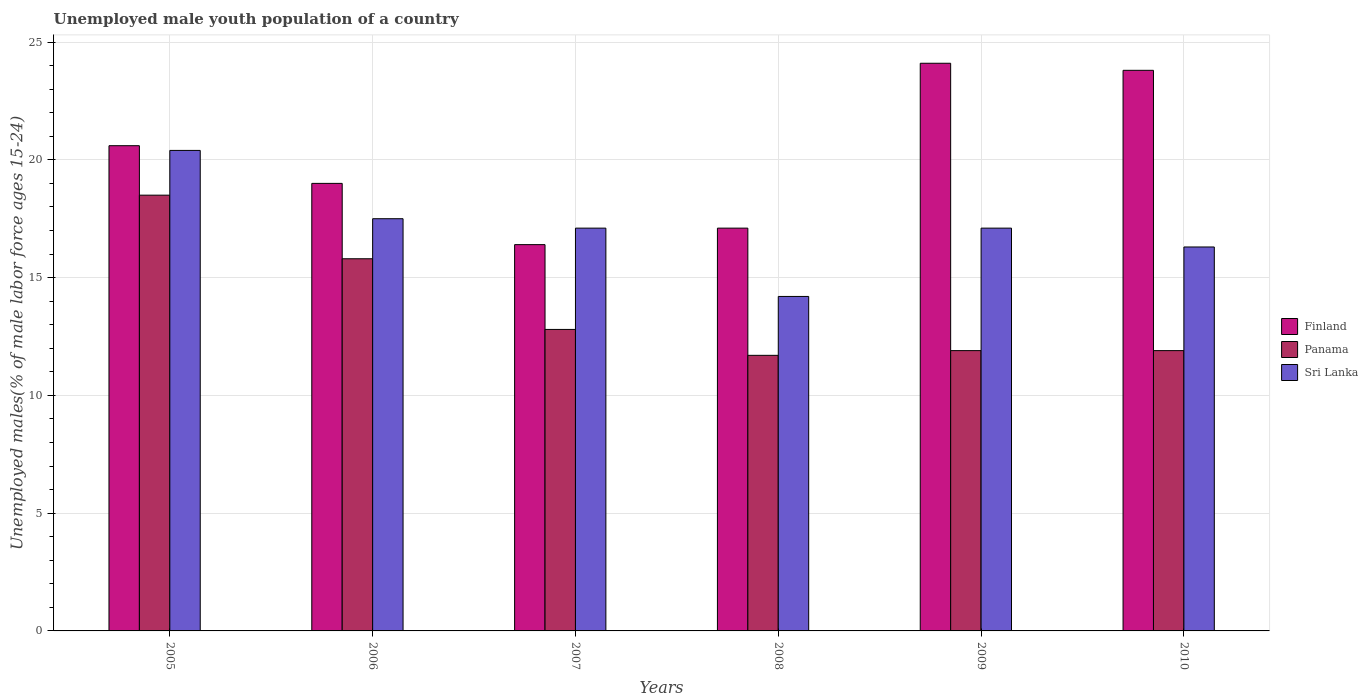How many different coloured bars are there?
Provide a succinct answer. 3. How many groups of bars are there?
Ensure brevity in your answer.  6. Are the number of bars per tick equal to the number of legend labels?
Make the answer very short. Yes. Are the number of bars on each tick of the X-axis equal?
Your response must be concise. Yes. What is the label of the 1st group of bars from the left?
Keep it short and to the point. 2005. In how many cases, is the number of bars for a given year not equal to the number of legend labels?
Keep it short and to the point. 0. What is the percentage of unemployed male youth population in Finland in 2006?
Ensure brevity in your answer.  19. Across all years, what is the minimum percentage of unemployed male youth population in Finland?
Make the answer very short. 16.4. In which year was the percentage of unemployed male youth population in Finland minimum?
Provide a succinct answer. 2007. What is the total percentage of unemployed male youth population in Finland in the graph?
Offer a terse response. 121. What is the difference between the percentage of unemployed male youth population in Sri Lanka in 2007 and that in 2008?
Ensure brevity in your answer.  2.9. What is the difference between the percentage of unemployed male youth population in Sri Lanka in 2005 and the percentage of unemployed male youth population in Finland in 2009?
Your response must be concise. -3.7. What is the average percentage of unemployed male youth population in Panama per year?
Your answer should be compact. 13.77. In the year 2009, what is the difference between the percentage of unemployed male youth population in Sri Lanka and percentage of unemployed male youth population in Panama?
Your answer should be very brief. 5.2. What is the ratio of the percentage of unemployed male youth population in Finland in 2008 to that in 2010?
Give a very brief answer. 0.72. Is the percentage of unemployed male youth population in Finland in 2009 less than that in 2010?
Your response must be concise. No. What is the difference between the highest and the second highest percentage of unemployed male youth population in Panama?
Make the answer very short. 2.7. What is the difference between the highest and the lowest percentage of unemployed male youth population in Panama?
Your answer should be compact. 6.8. Is the sum of the percentage of unemployed male youth population in Finland in 2006 and 2008 greater than the maximum percentage of unemployed male youth population in Sri Lanka across all years?
Give a very brief answer. Yes. Is it the case that in every year, the sum of the percentage of unemployed male youth population in Panama and percentage of unemployed male youth population in Sri Lanka is greater than the percentage of unemployed male youth population in Finland?
Your answer should be compact. Yes. Are all the bars in the graph horizontal?
Offer a very short reply. No. How many years are there in the graph?
Ensure brevity in your answer.  6. What is the difference between two consecutive major ticks on the Y-axis?
Your response must be concise. 5. Are the values on the major ticks of Y-axis written in scientific E-notation?
Your response must be concise. No. Does the graph contain grids?
Give a very brief answer. Yes. Where does the legend appear in the graph?
Your response must be concise. Center right. What is the title of the graph?
Your answer should be very brief. Unemployed male youth population of a country. What is the label or title of the X-axis?
Provide a succinct answer. Years. What is the label or title of the Y-axis?
Offer a very short reply. Unemployed males(% of male labor force ages 15-24). What is the Unemployed males(% of male labor force ages 15-24) in Finland in 2005?
Provide a short and direct response. 20.6. What is the Unemployed males(% of male labor force ages 15-24) of Panama in 2005?
Provide a succinct answer. 18.5. What is the Unemployed males(% of male labor force ages 15-24) of Sri Lanka in 2005?
Your answer should be very brief. 20.4. What is the Unemployed males(% of male labor force ages 15-24) of Finland in 2006?
Offer a terse response. 19. What is the Unemployed males(% of male labor force ages 15-24) of Panama in 2006?
Your response must be concise. 15.8. What is the Unemployed males(% of male labor force ages 15-24) of Finland in 2007?
Your response must be concise. 16.4. What is the Unemployed males(% of male labor force ages 15-24) of Panama in 2007?
Offer a terse response. 12.8. What is the Unemployed males(% of male labor force ages 15-24) in Sri Lanka in 2007?
Make the answer very short. 17.1. What is the Unemployed males(% of male labor force ages 15-24) of Finland in 2008?
Your answer should be compact. 17.1. What is the Unemployed males(% of male labor force ages 15-24) of Panama in 2008?
Provide a succinct answer. 11.7. What is the Unemployed males(% of male labor force ages 15-24) in Sri Lanka in 2008?
Provide a short and direct response. 14.2. What is the Unemployed males(% of male labor force ages 15-24) in Finland in 2009?
Offer a terse response. 24.1. What is the Unemployed males(% of male labor force ages 15-24) of Panama in 2009?
Your answer should be compact. 11.9. What is the Unemployed males(% of male labor force ages 15-24) of Sri Lanka in 2009?
Your answer should be very brief. 17.1. What is the Unemployed males(% of male labor force ages 15-24) in Finland in 2010?
Keep it short and to the point. 23.8. What is the Unemployed males(% of male labor force ages 15-24) in Panama in 2010?
Make the answer very short. 11.9. What is the Unemployed males(% of male labor force ages 15-24) of Sri Lanka in 2010?
Your answer should be very brief. 16.3. Across all years, what is the maximum Unemployed males(% of male labor force ages 15-24) in Finland?
Keep it short and to the point. 24.1. Across all years, what is the maximum Unemployed males(% of male labor force ages 15-24) of Panama?
Give a very brief answer. 18.5. Across all years, what is the maximum Unemployed males(% of male labor force ages 15-24) of Sri Lanka?
Give a very brief answer. 20.4. Across all years, what is the minimum Unemployed males(% of male labor force ages 15-24) of Finland?
Keep it short and to the point. 16.4. Across all years, what is the minimum Unemployed males(% of male labor force ages 15-24) in Panama?
Give a very brief answer. 11.7. Across all years, what is the minimum Unemployed males(% of male labor force ages 15-24) in Sri Lanka?
Keep it short and to the point. 14.2. What is the total Unemployed males(% of male labor force ages 15-24) in Finland in the graph?
Your answer should be compact. 121. What is the total Unemployed males(% of male labor force ages 15-24) in Panama in the graph?
Ensure brevity in your answer.  82.6. What is the total Unemployed males(% of male labor force ages 15-24) in Sri Lanka in the graph?
Your answer should be very brief. 102.6. What is the difference between the Unemployed males(% of male labor force ages 15-24) of Panama in 2005 and that in 2006?
Offer a very short reply. 2.7. What is the difference between the Unemployed males(% of male labor force ages 15-24) of Panama in 2005 and that in 2007?
Give a very brief answer. 5.7. What is the difference between the Unemployed males(% of male labor force ages 15-24) of Finland in 2005 and that in 2008?
Your answer should be compact. 3.5. What is the difference between the Unemployed males(% of male labor force ages 15-24) of Sri Lanka in 2005 and that in 2008?
Keep it short and to the point. 6.2. What is the difference between the Unemployed males(% of male labor force ages 15-24) in Sri Lanka in 2005 and that in 2010?
Offer a terse response. 4.1. What is the difference between the Unemployed males(% of male labor force ages 15-24) in Sri Lanka in 2006 and that in 2007?
Offer a very short reply. 0.4. What is the difference between the Unemployed males(% of male labor force ages 15-24) of Sri Lanka in 2006 and that in 2008?
Offer a terse response. 3.3. What is the difference between the Unemployed males(% of male labor force ages 15-24) in Finland in 2006 and that in 2009?
Offer a very short reply. -5.1. What is the difference between the Unemployed males(% of male labor force ages 15-24) in Panama in 2006 and that in 2010?
Provide a short and direct response. 3.9. What is the difference between the Unemployed males(% of male labor force ages 15-24) of Sri Lanka in 2006 and that in 2010?
Your answer should be compact. 1.2. What is the difference between the Unemployed males(% of male labor force ages 15-24) of Panama in 2007 and that in 2008?
Your answer should be very brief. 1.1. What is the difference between the Unemployed males(% of male labor force ages 15-24) in Sri Lanka in 2007 and that in 2008?
Your answer should be very brief. 2.9. What is the difference between the Unemployed males(% of male labor force ages 15-24) in Sri Lanka in 2007 and that in 2009?
Make the answer very short. 0. What is the difference between the Unemployed males(% of male labor force ages 15-24) of Finland in 2007 and that in 2010?
Provide a short and direct response. -7.4. What is the difference between the Unemployed males(% of male labor force ages 15-24) in Panama in 2008 and that in 2009?
Keep it short and to the point. -0.2. What is the difference between the Unemployed males(% of male labor force ages 15-24) of Panama in 2008 and that in 2010?
Your answer should be very brief. -0.2. What is the difference between the Unemployed males(% of male labor force ages 15-24) in Sri Lanka in 2008 and that in 2010?
Offer a terse response. -2.1. What is the difference between the Unemployed males(% of male labor force ages 15-24) of Finland in 2009 and that in 2010?
Keep it short and to the point. 0.3. What is the difference between the Unemployed males(% of male labor force ages 15-24) of Sri Lanka in 2009 and that in 2010?
Make the answer very short. 0.8. What is the difference between the Unemployed males(% of male labor force ages 15-24) in Finland in 2005 and the Unemployed males(% of male labor force ages 15-24) in Panama in 2006?
Provide a short and direct response. 4.8. What is the difference between the Unemployed males(% of male labor force ages 15-24) of Finland in 2005 and the Unemployed males(% of male labor force ages 15-24) of Sri Lanka in 2007?
Ensure brevity in your answer.  3.5. What is the difference between the Unemployed males(% of male labor force ages 15-24) in Panama in 2005 and the Unemployed males(% of male labor force ages 15-24) in Sri Lanka in 2007?
Your answer should be very brief. 1.4. What is the difference between the Unemployed males(% of male labor force ages 15-24) of Finland in 2005 and the Unemployed males(% of male labor force ages 15-24) of Panama in 2008?
Your response must be concise. 8.9. What is the difference between the Unemployed males(% of male labor force ages 15-24) of Finland in 2005 and the Unemployed males(% of male labor force ages 15-24) of Sri Lanka in 2008?
Provide a succinct answer. 6.4. What is the difference between the Unemployed males(% of male labor force ages 15-24) of Panama in 2005 and the Unemployed males(% of male labor force ages 15-24) of Sri Lanka in 2008?
Ensure brevity in your answer.  4.3. What is the difference between the Unemployed males(% of male labor force ages 15-24) in Finland in 2005 and the Unemployed males(% of male labor force ages 15-24) in Sri Lanka in 2009?
Offer a terse response. 3.5. What is the difference between the Unemployed males(% of male labor force ages 15-24) of Panama in 2005 and the Unemployed males(% of male labor force ages 15-24) of Sri Lanka in 2009?
Provide a short and direct response. 1.4. What is the difference between the Unemployed males(% of male labor force ages 15-24) of Finland in 2005 and the Unemployed males(% of male labor force ages 15-24) of Panama in 2010?
Offer a terse response. 8.7. What is the difference between the Unemployed males(% of male labor force ages 15-24) in Panama in 2006 and the Unemployed males(% of male labor force ages 15-24) in Sri Lanka in 2007?
Offer a terse response. -1.3. What is the difference between the Unemployed males(% of male labor force ages 15-24) of Finland in 2006 and the Unemployed males(% of male labor force ages 15-24) of Panama in 2008?
Your response must be concise. 7.3. What is the difference between the Unemployed males(% of male labor force ages 15-24) of Panama in 2006 and the Unemployed males(% of male labor force ages 15-24) of Sri Lanka in 2008?
Offer a very short reply. 1.6. What is the difference between the Unemployed males(% of male labor force ages 15-24) in Finland in 2006 and the Unemployed males(% of male labor force ages 15-24) in Panama in 2010?
Your response must be concise. 7.1. What is the difference between the Unemployed males(% of male labor force ages 15-24) in Finland in 2006 and the Unemployed males(% of male labor force ages 15-24) in Sri Lanka in 2010?
Offer a terse response. 2.7. What is the difference between the Unemployed males(% of male labor force ages 15-24) in Panama in 2006 and the Unemployed males(% of male labor force ages 15-24) in Sri Lanka in 2010?
Offer a terse response. -0.5. What is the difference between the Unemployed males(% of male labor force ages 15-24) in Panama in 2007 and the Unemployed males(% of male labor force ages 15-24) in Sri Lanka in 2008?
Your answer should be very brief. -1.4. What is the difference between the Unemployed males(% of male labor force ages 15-24) of Finland in 2007 and the Unemployed males(% of male labor force ages 15-24) of Panama in 2009?
Your answer should be very brief. 4.5. What is the difference between the Unemployed males(% of male labor force ages 15-24) in Finland in 2007 and the Unemployed males(% of male labor force ages 15-24) in Sri Lanka in 2009?
Provide a succinct answer. -0.7. What is the difference between the Unemployed males(% of male labor force ages 15-24) in Panama in 2007 and the Unemployed males(% of male labor force ages 15-24) in Sri Lanka in 2009?
Your response must be concise. -4.3. What is the difference between the Unemployed males(% of male labor force ages 15-24) in Finland in 2007 and the Unemployed males(% of male labor force ages 15-24) in Sri Lanka in 2010?
Offer a very short reply. 0.1. What is the difference between the Unemployed males(% of male labor force ages 15-24) of Finland in 2008 and the Unemployed males(% of male labor force ages 15-24) of Panama in 2009?
Give a very brief answer. 5.2. What is the difference between the Unemployed males(% of male labor force ages 15-24) of Finland in 2008 and the Unemployed males(% of male labor force ages 15-24) of Sri Lanka in 2009?
Keep it short and to the point. 0. What is the difference between the Unemployed males(% of male labor force ages 15-24) in Panama in 2008 and the Unemployed males(% of male labor force ages 15-24) in Sri Lanka in 2009?
Offer a terse response. -5.4. What is the difference between the Unemployed males(% of male labor force ages 15-24) of Finland in 2008 and the Unemployed males(% of male labor force ages 15-24) of Panama in 2010?
Your answer should be very brief. 5.2. What is the difference between the Unemployed males(% of male labor force ages 15-24) of Finland in 2008 and the Unemployed males(% of male labor force ages 15-24) of Sri Lanka in 2010?
Your response must be concise. 0.8. What is the difference between the Unemployed males(% of male labor force ages 15-24) in Panama in 2008 and the Unemployed males(% of male labor force ages 15-24) in Sri Lanka in 2010?
Make the answer very short. -4.6. What is the difference between the Unemployed males(% of male labor force ages 15-24) of Finland in 2009 and the Unemployed males(% of male labor force ages 15-24) of Sri Lanka in 2010?
Provide a short and direct response. 7.8. What is the average Unemployed males(% of male labor force ages 15-24) in Finland per year?
Your response must be concise. 20.17. What is the average Unemployed males(% of male labor force ages 15-24) in Panama per year?
Offer a very short reply. 13.77. What is the average Unemployed males(% of male labor force ages 15-24) of Sri Lanka per year?
Provide a succinct answer. 17.1. In the year 2005, what is the difference between the Unemployed males(% of male labor force ages 15-24) of Finland and Unemployed males(% of male labor force ages 15-24) of Sri Lanka?
Provide a succinct answer. 0.2. In the year 2006, what is the difference between the Unemployed males(% of male labor force ages 15-24) in Panama and Unemployed males(% of male labor force ages 15-24) in Sri Lanka?
Your response must be concise. -1.7. In the year 2007, what is the difference between the Unemployed males(% of male labor force ages 15-24) in Finland and Unemployed males(% of male labor force ages 15-24) in Sri Lanka?
Your answer should be very brief. -0.7. In the year 2008, what is the difference between the Unemployed males(% of male labor force ages 15-24) of Finland and Unemployed males(% of male labor force ages 15-24) of Panama?
Your answer should be very brief. 5.4. In the year 2008, what is the difference between the Unemployed males(% of male labor force ages 15-24) of Finland and Unemployed males(% of male labor force ages 15-24) of Sri Lanka?
Offer a very short reply. 2.9. In the year 2008, what is the difference between the Unemployed males(% of male labor force ages 15-24) of Panama and Unemployed males(% of male labor force ages 15-24) of Sri Lanka?
Give a very brief answer. -2.5. In the year 2009, what is the difference between the Unemployed males(% of male labor force ages 15-24) in Finland and Unemployed males(% of male labor force ages 15-24) in Sri Lanka?
Make the answer very short. 7. In the year 2009, what is the difference between the Unemployed males(% of male labor force ages 15-24) of Panama and Unemployed males(% of male labor force ages 15-24) of Sri Lanka?
Your response must be concise. -5.2. In the year 2010, what is the difference between the Unemployed males(% of male labor force ages 15-24) in Finland and Unemployed males(% of male labor force ages 15-24) in Panama?
Your answer should be very brief. 11.9. In the year 2010, what is the difference between the Unemployed males(% of male labor force ages 15-24) of Finland and Unemployed males(% of male labor force ages 15-24) of Sri Lanka?
Your answer should be very brief. 7.5. What is the ratio of the Unemployed males(% of male labor force ages 15-24) in Finland in 2005 to that in 2006?
Keep it short and to the point. 1.08. What is the ratio of the Unemployed males(% of male labor force ages 15-24) in Panama in 2005 to that in 2006?
Offer a very short reply. 1.17. What is the ratio of the Unemployed males(% of male labor force ages 15-24) of Sri Lanka in 2005 to that in 2006?
Give a very brief answer. 1.17. What is the ratio of the Unemployed males(% of male labor force ages 15-24) of Finland in 2005 to that in 2007?
Your answer should be compact. 1.26. What is the ratio of the Unemployed males(% of male labor force ages 15-24) in Panama in 2005 to that in 2007?
Keep it short and to the point. 1.45. What is the ratio of the Unemployed males(% of male labor force ages 15-24) of Sri Lanka in 2005 to that in 2007?
Provide a short and direct response. 1.19. What is the ratio of the Unemployed males(% of male labor force ages 15-24) of Finland in 2005 to that in 2008?
Provide a short and direct response. 1.2. What is the ratio of the Unemployed males(% of male labor force ages 15-24) in Panama in 2005 to that in 2008?
Your answer should be compact. 1.58. What is the ratio of the Unemployed males(% of male labor force ages 15-24) of Sri Lanka in 2005 to that in 2008?
Your response must be concise. 1.44. What is the ratio of the Unemployed males(% of male labor force ages 15-24) in Finland in 2005 to that in 2009?
Keep it short and to the point. 0.85. What is the ratio of the Unemployed males(% of male labor force ages 15-24) of Panama in 2005 to that in 2009?
Offer a terse response. 1.55. What is the ratio of the Unemployed males(% of male labor force ages 15-24) of Sri Lanka in 2005 to that in 2009?
Your response must be concise. 1.19. What is the ratio of the Unemployed males(% of male labor force ages 15-24) in Finland in 2005 to that in 2010?
Your answer should be compact. 0.87. What is the ratio of the Unemployed males(% of male labor force ages 15-24) in Panama in 2005 to that in 2010?
Ensure brevity in your answer.  1.55. What is the ratio of the Unemployed males(% of male labor force ages 15-24) of Sri Lanka in 2005 to that in 2010?
Give a very brief answer. 1.25. What is the ratio of the Unemployed males(% of male labor force ages 15-24) in Finland in 2006 to that in 2007?
Offer a very short reply. 1.16. What is the ratio of the Unemployed males(% of male labor force ages 15-24) in Panama in 2006 to that in 2007?
Your answer should be very brief. 1.23. What is the ratio of the Unemployed males(% of male labor force ages 15-24) in Sri Lanka in 2006 to that in 2007?
Ensure brevity in your answer.  1.02. What is the ratio of the Unemployed males(% of male labor force ages 15-24) in Finland in 2006 to that in 2008?
Offer a very short reply. 1.11. What is the ratio of the Unemployed males(% of male labor force ages 15-24) of Panama in 2006 to that in 2008?
Your answer should be very brief. 1.35. What is the ratio of the Unemployed males(% of male labor force ages 15-24) in Sri Lanka in 2006 to that in 2008?
Make the answer very short. 1.23. What is the ratio of the Unemployed males(% of male labor force ages 15-24) in Finland in 2006 to that in 2009?
Provide a short and direct response. 0.79. What is the ratio of the Unemployed males(% of male labor force ages 15-24) of Panama in 2006 to that in 2009?
Give a very brief answer. 1.33. What is the ratio of the Unemployed males(% of male labor force ages 15-24) in Sri Lanka in 2006 to that in 2009?
Give a very brief answer. 1.02. What is the ratio of the Unemployed males(% of male labor force ages 15-24) of Finland in 2006 to that in 2010?
Your response must be concise. 0.8. What is the ratio of the Unemployed males(% of male labor force ages 15-24) in Panama in 2006 to that in 2010?
Provide a succinct answer. 1.33. What is the ratio of the Unemployed males(% of male labor force ages 15-24) of Sri Lanka in 2006 to that in 2010?
Your response must be concise. 1.07. What is the ratio of the Unemployed males(% of male labor force ages 15-24) of Finland in 2007 to that in 2008?
Ensure brevity in your answer.  0.96. What is the ratio of the Unemployed males(% of male labor force ages 15-24) in Panama in 2007 to that in 2008?
Your response must be concise. 1.09. What is the ratio of the Unemployed males(% of male labor force ages 15-24) in Sri Lanka in 2007 to that in 2008?
Provide a short and direct response. 1.2. What is the ratio of the Unemployed males(% of male labor force ages 15-24) in Finland in 2007 to that in 2009?
Give a very brief answer. 0.68. What is the ratio of the Unemployed males(% of male labor force ages 15-24) of Panama in 2007 to that in 2009?
Your response must be concise. 1.08. What is the ratio of the Unemployed males(% of male labor force ages 15-24) in Sri Lanka in 2007 to that in 2009?
Your response must be concise. 1. What is the ratio of the Unemployed males(% of male labor force ages 15-24) in Finland in 2007 to that in 2010?
Offer a terse response. 0.69. What is the ratio of the Unemployed males(% of male labor force ages 15-24) of Panama in 2007 to that in 2010?
Provide a short and direct response. 1.08. What is the ratio of the Unemployed males(% of male labor force ages 15-24) of Sri Lanka in 2007 to that in 2010?
Offer a terse response. 1.05. What is the ratio of the Unemployed males(% of male labor force ages 15-24) of Finland in 2008 to that in 2009?
Ensure brevity in your answer.  0.71. What is the ratio of the Unemployed males(% of male labor force ages 15-24) in Panama in 2008 to that in 2009?
Ensure brevity in your answer.  0.98. What is the ratio of the Unemployed males(% of male labor force ages 15-24) of Sri Lanka in 2008 to that in 2009?
Provide a succinct answer. 0.83. What is the ratio of the Unemployed males(% of male labor force ages 15-24) of Finland in 2008 to that in 2010?
Offer a very short reply. 0.72. What is the ratio of the Unemployed males(% of male labor force ages 15-24) in Panama in 2008 to that in 2010?
Your answer should be compact. 0.98. What is the ratio of the Unemployed males(% of male labor force ages 15-24) in Sri Lanka in 2008 to that in 2010?
Offer a terse response. 0.87. What is the ratio of the Unemployed males(% of male labor force ages 15-24) of Finland in 2009 to that in 2010?
Offer a terse response. 1.01. What is the ratio of the Unemployed males(% of male labor force ages 15-24) of Sri Lanka in 2009 to that in 2010?
Make the answer very short. 1.05. What is the difference between the highest and the second highest Unemployed males(% of male labor force ages 15-24) in Finland?
Give a very brief answer. 0.3. What is the difference between the highest and the lowest Unemployed males(% of male labor force ages 15-24) in Sri Lanka?
Make the answer very short. 6.2. 